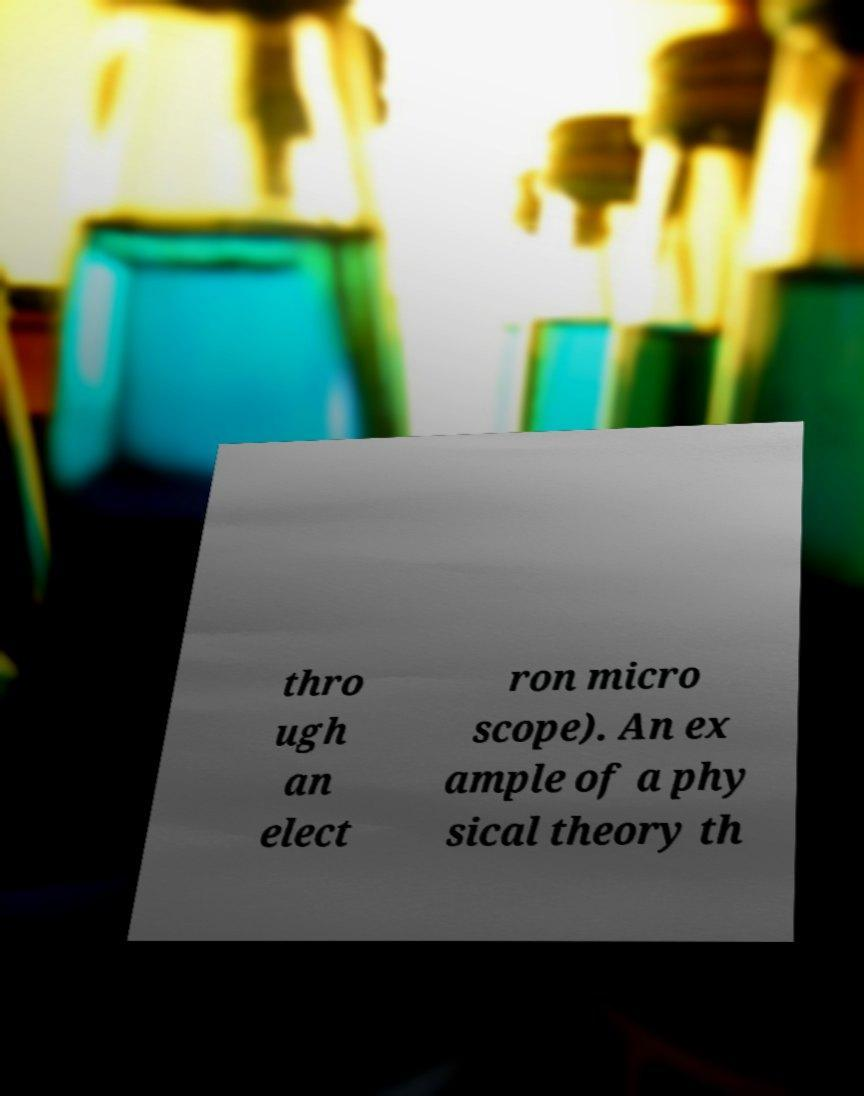For documentation purposes, I need the text within this image transcribed. Could you provide that? thro ugh an elect ron micro scope). An ex ample of a phy sical theory th 